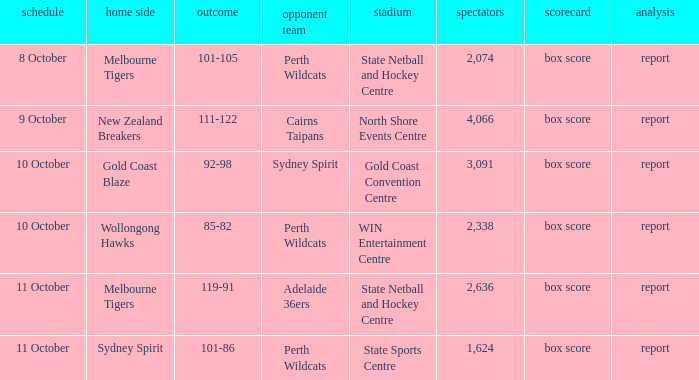What was the crowd size for the game with a score of 101-105? 2074.0. Could you parse the entire table as a dict? {'header': ['schedule', 'home side', 'outcome', 'opponent team', 'stadium', 'spectators', 'scorecard', 'analysis'], 'rows': [['8 October', 'Melbourne Tigers', '101-105', 'Perth Wildcats', 'State Netball and Hockey Centre', '2,074', 'box score', 'report'], ['9 October', 'New Zealand Breakers', '111-122', 'Cairns Taipans', 'North Shore Events Centre', '4,066', 'box score', 'report'], ['10 October', 'Gold Coast Blaze', '92-98', 'Sydney Spirit', 'Gold Coast Convention Centre', '3,091', 'box score', 'report'], ['10 October', 'Wollongong Hawks', '85-82', 'Perth Wildcats', 'WIN Entertainment Centre', '2,338', 'box score', 'report'], ['11 October', 'Melbourne Tigers', '119-91', 'Adelaide 36ers', 'State Netball and Hockey Centre', '2,636', 'box score', 'report'], ['11 October', 'Sydney Spirit', '101-86', 'Perth Wildcats', 'State Sports Centre', '1,624', 'box score', 'report']]} 